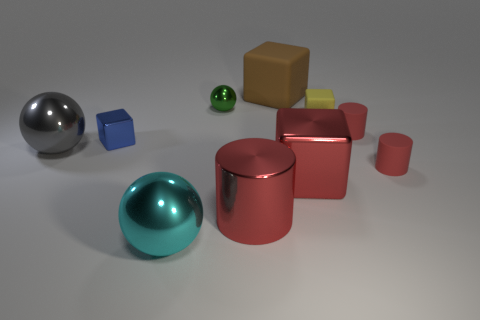There is a cube that is the same color as the big cylinder; what is its size?
Provide a succinct answer. Large. Are there more blocks that are left of the brown block than big cyan shiny balls?
Provide a succinct answer. No. Do the yellow object and the red thing that is behind the gray ball have the same shape?
Give a very brief answer. No. How many other red cylinders are the same size as the red shiny cylinder?
Offer a very short reply. 0. There is a small cube that is behind the red cylinder behind the tiny shiny block; what number of large red metal objects are behind it?
Ensure brevity in your answer.  0. Are there an equal number of tiny shiny objects to the right of the tiny green metal thing and rubber cubes that are in front of the yellow rubber thing?
Offer a terse response. Yes. What number of large red things have the same shape as the tiny blue object?
Offer a very short reply. 1. Are there any large brown things that have the same material as the green ball?
Your answer should be compact. No. The large metallic object that is the same color as the metallic cylinder is what shape?
Give a very brief answer. Cube. How many cubes are there?
Your answer should be compact. 4. 